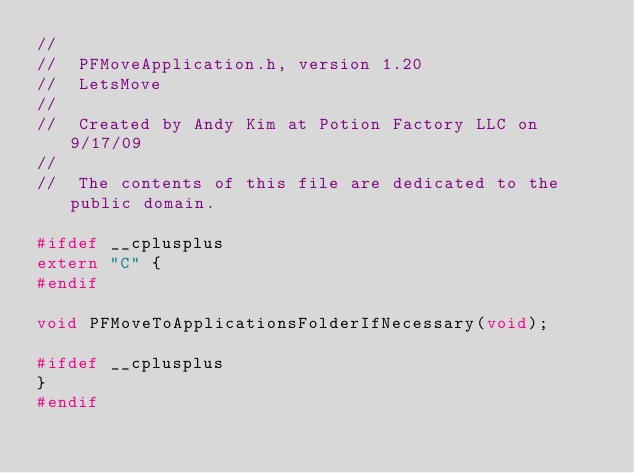<code> <loc_0><loc_0><loc_500><loc_500><_C_>//
//  PFMoveApplication.h, version 1.20
//  LetsMove
//
//  Created by Andy Kim at Potion Factory LLC on 9/17/09
//
//  The contents of this file are dedicated to the public domain.

#ifdef __cplusplus
extern "C" {
#endif

void PFMoveToApplicationsFolderIfNecessary(void);

#ifdef __cplusplus
}
#endif
</code> 